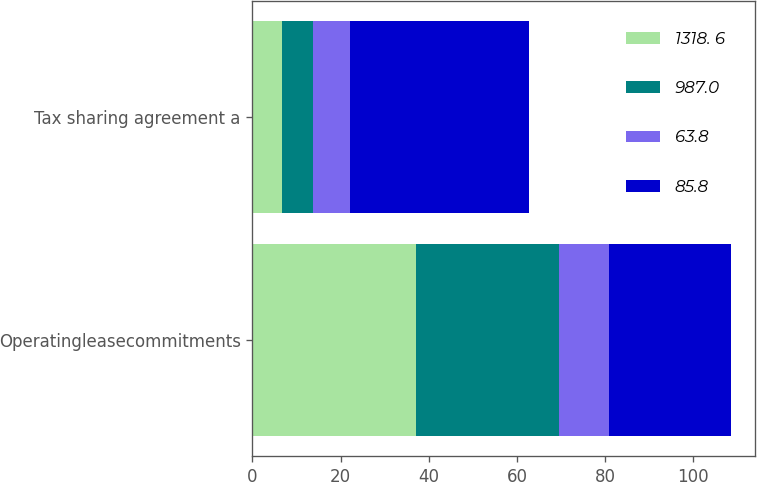Convert chart to OTSL. <chart><loc_0><loc_0><loc_500><loc_500><stacked_bar_chart><ecel><fcel>Operatingleasecommitments<fcel>Tax sharing agreement a<nl><fcel>1318. 6<fcel>37.1<fcel>6.7<nl><fcel>987.0<fcel>32.4<fcel>7<nl><fcel>63.8<fcel>11.3<fcel>8.5<nl><fcel>85.8<fcel>27.7<fcel>40.6<nl></chart> 